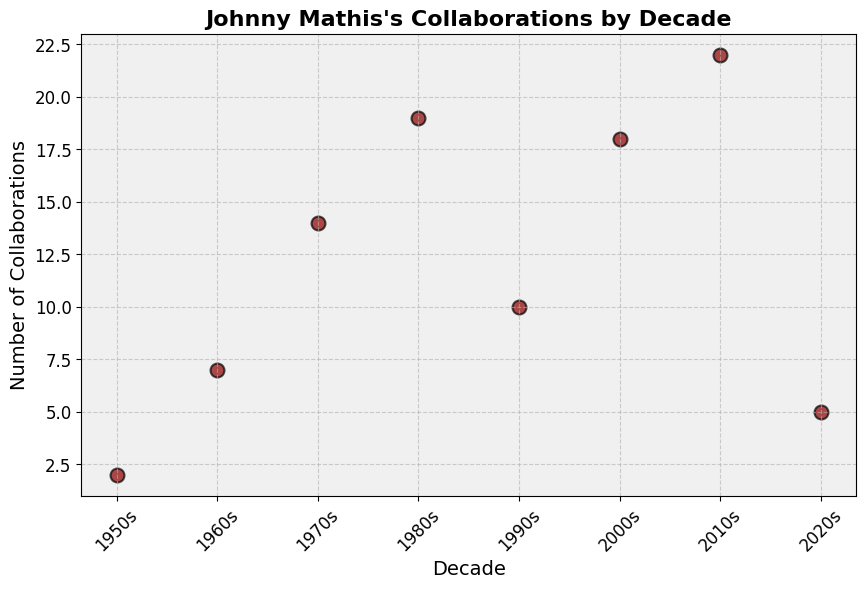What is the total number of collaborations Johnny Mathis had in the 1980s and 1990s? Adding the number of collaborations in the 1980s (19) to those in the 1990s (10) gives the total number of collaborations for these two decades: 19 + 10 = 29.
Answer: 29 Which decade had the highest number of collaborations? By looking at the scatter plot, the 2010s had the highest number of collaborations with a value of 22.
Answer: 2010s How many more collaborations did Johnny Mathis have in the 2000s compared to the 2020s? The number of collaborations in the 2000s is 18, while in the 2020s it is 5. Subtracting the latter from the former gives: 18 - 5 = 13.
Answer: 13 What is the average number of collaborations per decade, across all decades? Summing up all the collaborations: 2 + 7 + 14 + 19 + 10 + 18 + 22 + 5 = 97. Dividing this sum by the number of decades (8) gives the average: 97 / 8 = 12.125.
Answer: 12.125 In which decade did Johnny Mathis's number of collaborations increase the most compared to the previous decade? Comparing the differences: 1960s - 1950s (7-2=5), 1970s - 1960s (14-7=7), 1980s - 1970s (19-14=5), 1990s - 1980s (10-19=-9), 2000s - 1990s (18-10=8), 2010s - 2000s (22-18=4), 2020s - 2010s (5-22=-17). The biggest increase is 8 collaborations from the 1990s to the 2000s.
Answer: 2000s How many decades saw a decrease in the number of collaborations compared to the previous decade? By observing the plot, the number of collaborations decreases in the following transitions: 1980s to 1990s (19 to 10), and 2010s to 2020s (22 to 5). So, there are 2 such decades.
Answer: 2 What is the range of the number of collaborations across all decades? The maximum number of collaborations is 22 (2010s), and the minimum is 2 (1950s). The range is calculated as 22 - 2 = 20.
Answer: 20 Which decade had the lowest number of collaborations? Referring to the plot, the 1950s had the lowest number of collaborations with a value of 2.
Answer: 1950s What is the median number of collaborations per decade? Ordering the numbers: 2, 5, 7, 10, 14, 18, 19, 22. With 8 data points, the median is the average of the 4th and 5th values: (10 + 14) / 2 = 12.
Answer: 12 